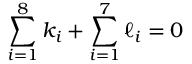Convert formula to latex. <formula><loc_0><loc_0><loc_500><loc_500>\sum _ { i = 1 } ^ { 8 } k _ { i } + \sum _ { i = 1 } ^ { 7 } \ell _ { i } = 0</formula> 